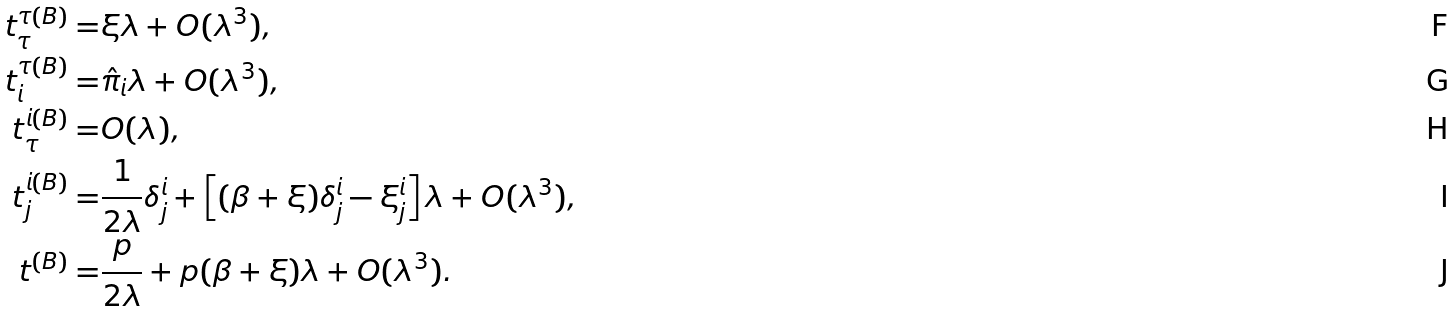<formula> <loc_0><loc_0><loc_500><loc_500>t _ { \tau } ^ { \tau ( B ) } = & \xi \lambda + O ( \lambda ^ { 3 } ) , \\ t _ { i } ^ { \tau ( B ) } = & \hat { \pi } _ { i } \lambda + O ( \lambda ^ { 3 } ) , \\ t _ { \tau } ^ { i ( B ) } = & O ( \lambda ) , \\ t _ { j } ^ { i ( B ) } = & \frac { 1 } { 2 \lambda } \delta _ { j } ^ { i } + \left [ ( \beta + \xi ) \delta _ { j } ^ { i } - \xi _ { j } ^ { i } \right ] \lambda + O ( \lambda ^ { 3 } ) , \\ t ^ { ( B ) } = & \frac { p } { 2 \lambda } + p ( \beta + \xi ) \lambda + O ( \lambda ^ { 3 } ) .</formula> 